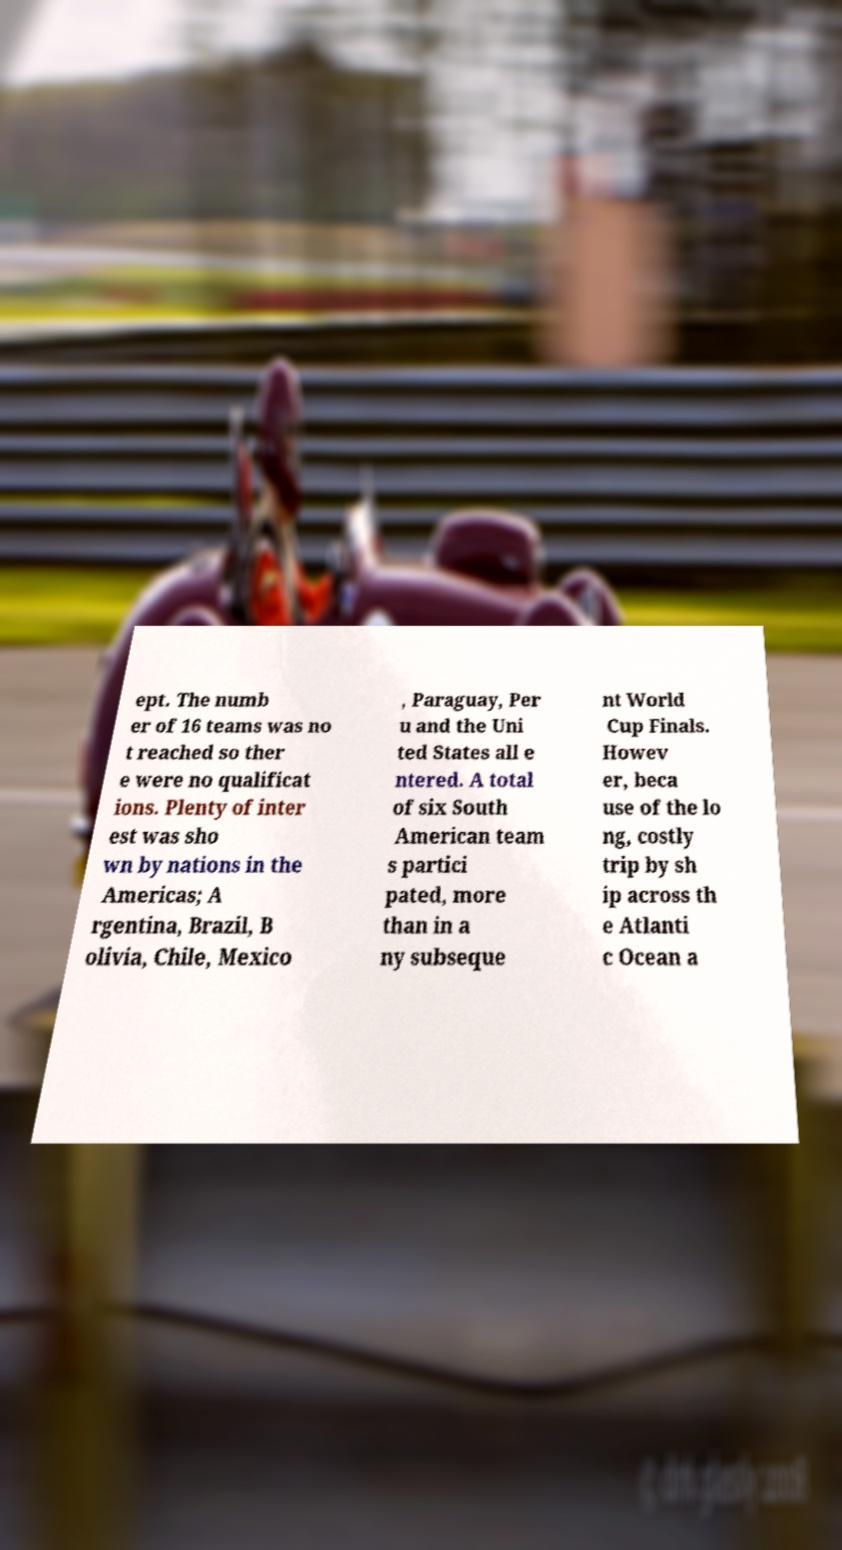Can you read and provide the text displayed in the image?This photo seems to have some interesting text. Can you extract and type it out for me? ept. The numb er of 16 teams was no t reached so ther e were no qualificat ions. Plenty of inter est was sho wn by nations in the Americas; A rgentina, Brazil, B olivia, Chile, Mexico , Paraguay, Per u and the Uni ted States all e ntered. A total of six South American team s partici pated, more than in a ny subseque nt World Cup Finals. Howev er, beca use of the lo ng, costly trip by sh ip across th e Atlanti c Ocean a 